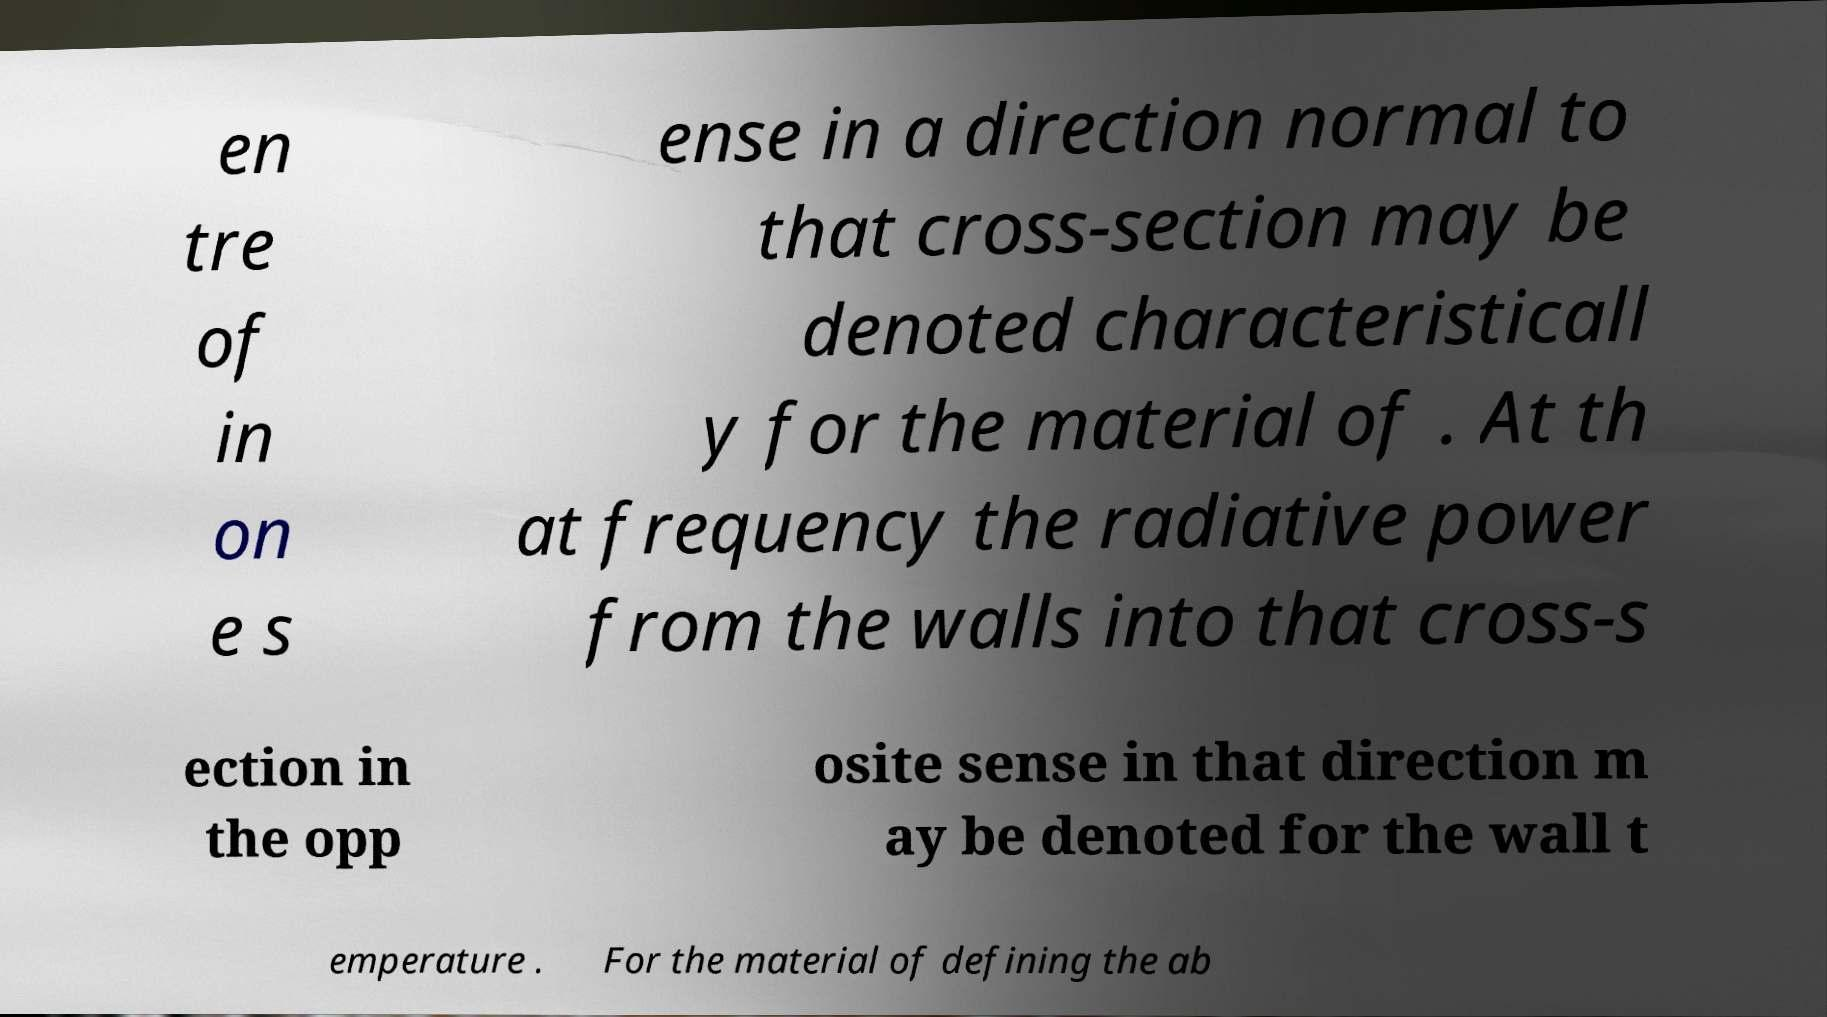I need the written content from this picture converted into text. Can you do that? en tre of in on e s ense in a direction normal to that cross-section may be denoted characteristicall y for the material of . At th at frequency the radiative power from the walls into that cross-s ection in the opp osite sense in that direction m ay be denoted for the wall t emperature . For the material of defining the ab 